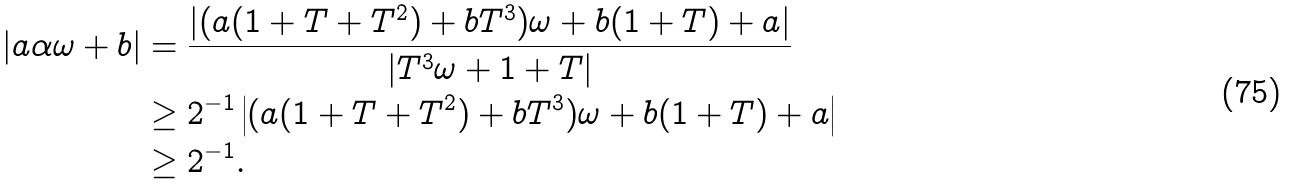Convert formula to latex. <formula><loc_0><loc_0><loc_500><loc_500>| a \alpha \omega + b | & = \frac { | ( a ( 1 + T + T ^ { 2 } ) + b T ^ { 3 } ) \omega + b ( 1 + T ) + a | } { | T ^ { 3 } \omega + 1 + T | } \\ & \geq 2 ^ { - 1 } \left | ( a ( 1 + T + T ^ { 2 } ) + b T ^ { 3 } ) \omega + b ( 1 + T ) + a \right | \\ & \geq 2 ^ { - 1 } .</formula> 